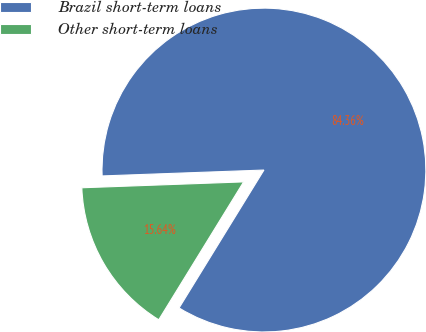Convert chart. <chart><loc_0><loc_0><loc_500><loc_500><pie_chart><fcel>Brazil short-term loans<fcel>Other short-term loans<nl><fcel>84.36%<fcel>15.64%<nl></chart> 